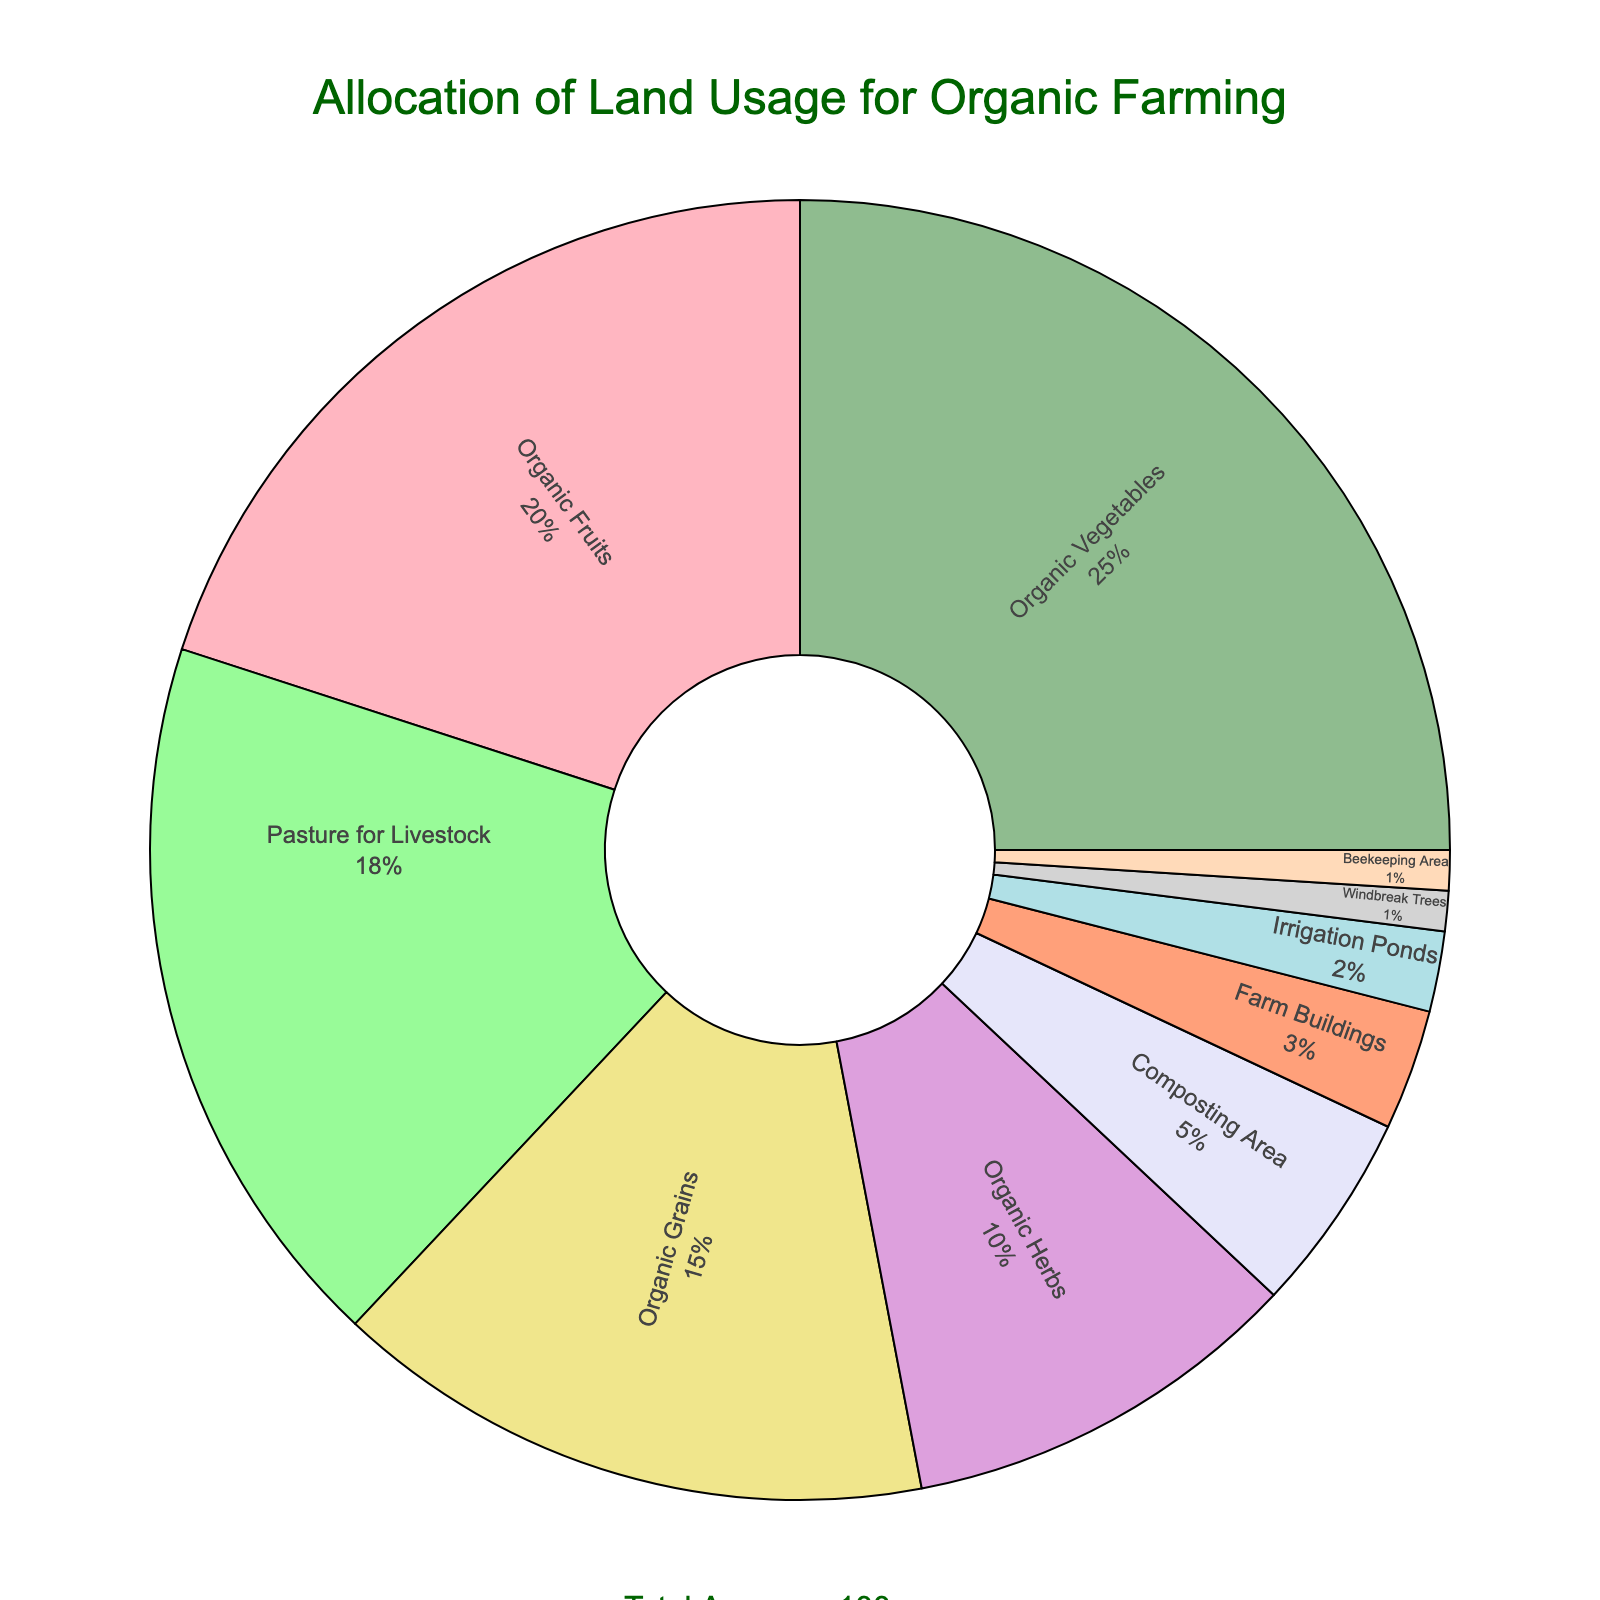what proportion of the total land is used for organic vegetable farming? To find the proportion, look at the slice labeled "Organic Vegetables" and note its percentage from the pie chart.
Answer: 25% Which farming activity occupies the second most land? First, identify which activity has the largest plot. Then, find the next largest. Organic Vegetables is the largest, so the next largest is Organic Fruits.
Answer: Organic Fruits What is the combined acreage of Organic Grains, Composting Area, and Beekeeping Area? Add the acreages: Organic Grains (15) + Composting Area (5) + Beekeeping Area (1) = 21 acres.
Answer: 21 acres How does the land allocated to Farm Buildings compare to the land allocated to Pasture for Livestock? Farm Buildings occupy 3 acres and Pasture for Livestock 18 acres. Compare these by subtracting: 18 - 3 = 15 acres less.
Answer: Farm Buildings occupy 15 acres less than Pasture for Livestock What's the difference in acreage between the area for Windbreak Trees and the Irrigation Ponds? Windbreak Trees occupy 1 acre and Irrigation Ponds 2 acres. The difference is: 2 - 1 = 1 acre.
Answer: 1 acre What percentage of the land is used for Pasture for Livestock? Locate the percentage for Pasture for Livestock from the pie chart to determine its proportion.
Answer: 18% If land for Organic Grains was increased by 5 acres, what would be the new total acreage for it? Original acreage for Organic Grains is 15 acres. If increased by 5, it will be: 15 + 5 = 20 acres.
Answer: 20 acres Between Beekeeping Area and Organic Herbs, which occupies more land and by how much? Compare the acreages: Beekeeping Area (1 acre) and Organic Herbs (10 acres). The difference is: 10 - 1 = 9 acres.
Answer: Organic Herbs by 9 acres What is the total acreage covered by the farming activities that use less than 5 acres each? Sum the acreages of activities using less than 5 acres: Composting Area (5), Beekeeping Area (1), Windbreak Trees (1), Irrigation Ponds (2), and Farm Buildings (3), but only the applicable ones: 1 + 1 + 2 = 4 acres.
Answer: 4 acres What percentage of the land usage is taken by non-plant related activities? Identify non-plant related activities: Pasture for Livestock (18), Composting Area (5), Farm Buildings (3), Irrigation Ponds (2), Beekeeping Area (1), Windbreak Trees (1). Total is: 18 + 5 + 3 + 2 + 1 + 1 = 30 acres.
Answer: 30% 